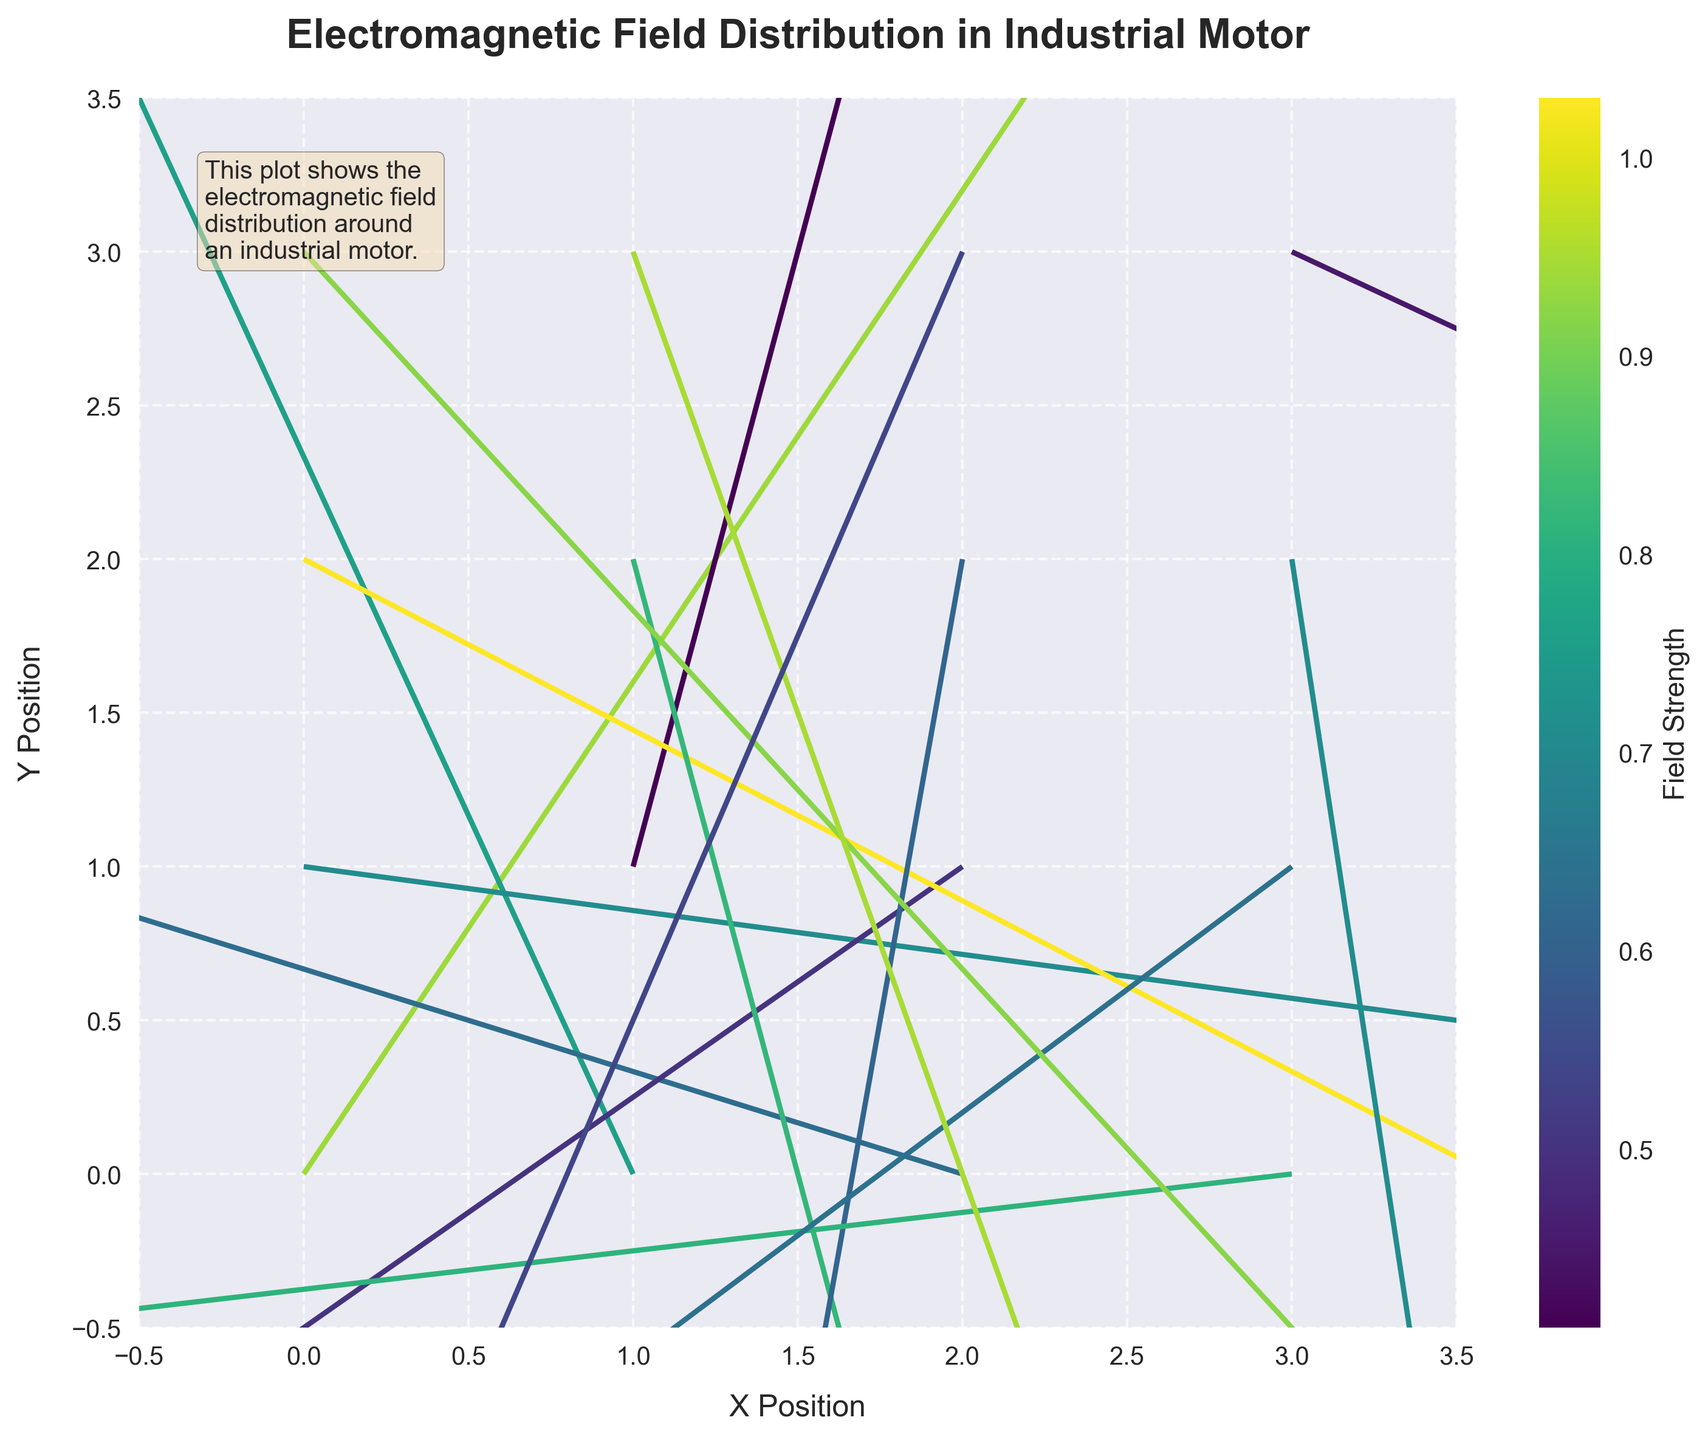What's the title of the plot? The title of the plot is usually placed at the top of the figure. It gives a brief idea of the content being depicted in the plot.
Answer: Electromagnetic Field Distribution in Industrial Motor What are the labels of the x and y axes? The labels of x and y axes help identify what each axis represents. In this plot, they should be stating the positions in terms of 'X Position' and 'Y Position'.
Answer: X Position, Y Position What is the color range indicating in the plot? The color range in a quiver plot is often represented using a color bar, which in this case, relates to the electromagnetic field strength.
Answer: Field Strength How many arrow origins are there in the plot? To find the number of arrow origins, simply count the number of (x, y) coordinate pairs present in the data.
Answer: 16 What is the direction of the arrow at position (1, 0)? By looking at the specific arrow at position (1, 0), its direction can be understood based on the u and v components where u = -0.3 and v = 0.7.
Answer: Upwards and slightly to the left Which position shows the highest field strength? To determine the position with the highest field strength, look at the color intensity and values in the color bar. The maximum field strength value should correspond to one of the positions. At (0, 2), strength is 1.03 which is the highest.
Answer: (0, 2) Compare the field strength at position (2, 3) and (3, 3). Which one is greater? By comparing the field strength values at both positions, which are 0.54 and 0.45 respectively, it's evident that (2, 3) has a greater field strength.
Answer: (2, 3) What is the average field strength value across all positions? Adding all the field strength values given and dividing by the number of positions, we get the average field strength: (0.94 + 0.76 + 0.63 + 0.71 + 0.41 + 0.5 + 1.03 + 0.82 + 0.61 + 0.81 + 0.64 + 0.71 + 0.92 + 0.95 + 0.54 + 0.45) / 16 = 0.70.
Answer: 0.70 How does the field direction at (0, 0) compare to that at (3, 1)? At (0, 0), the direction is upward to the right with components (0.5, 0.8), while at (3, 1), the direction points downward to the left with components (-0.5, -0.4). This indicates opposite directions.
Answer: Opposite directions What's the difference in field strength between (1, 3) and (3, 2)? The strength at (1, 3) is 0.95 and at (3, 2) is 0.71. The difference can be calculated as 0.95 - 0.71 = 0.24.
Answer: 0.24 